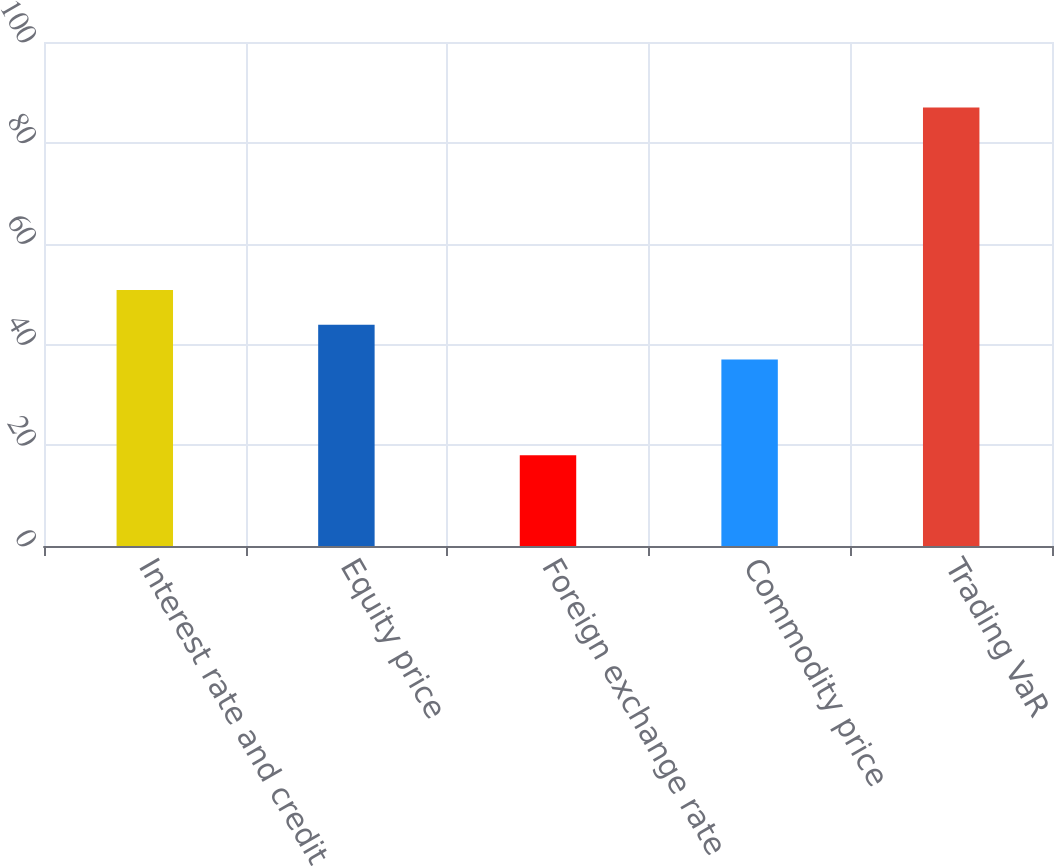<chart> <loc_0><loc_0><loc_500><loc_500><bar_chart><fcel>Interest rate and credit<fcel>Equity price<fcel>Foreign exchange rate<fcel>Commodity price<fcel>Trading VaR<nl><fcel>50.8<fcel>43.9<fcel>18<fcel>37<fcel>87<nl></chart> 